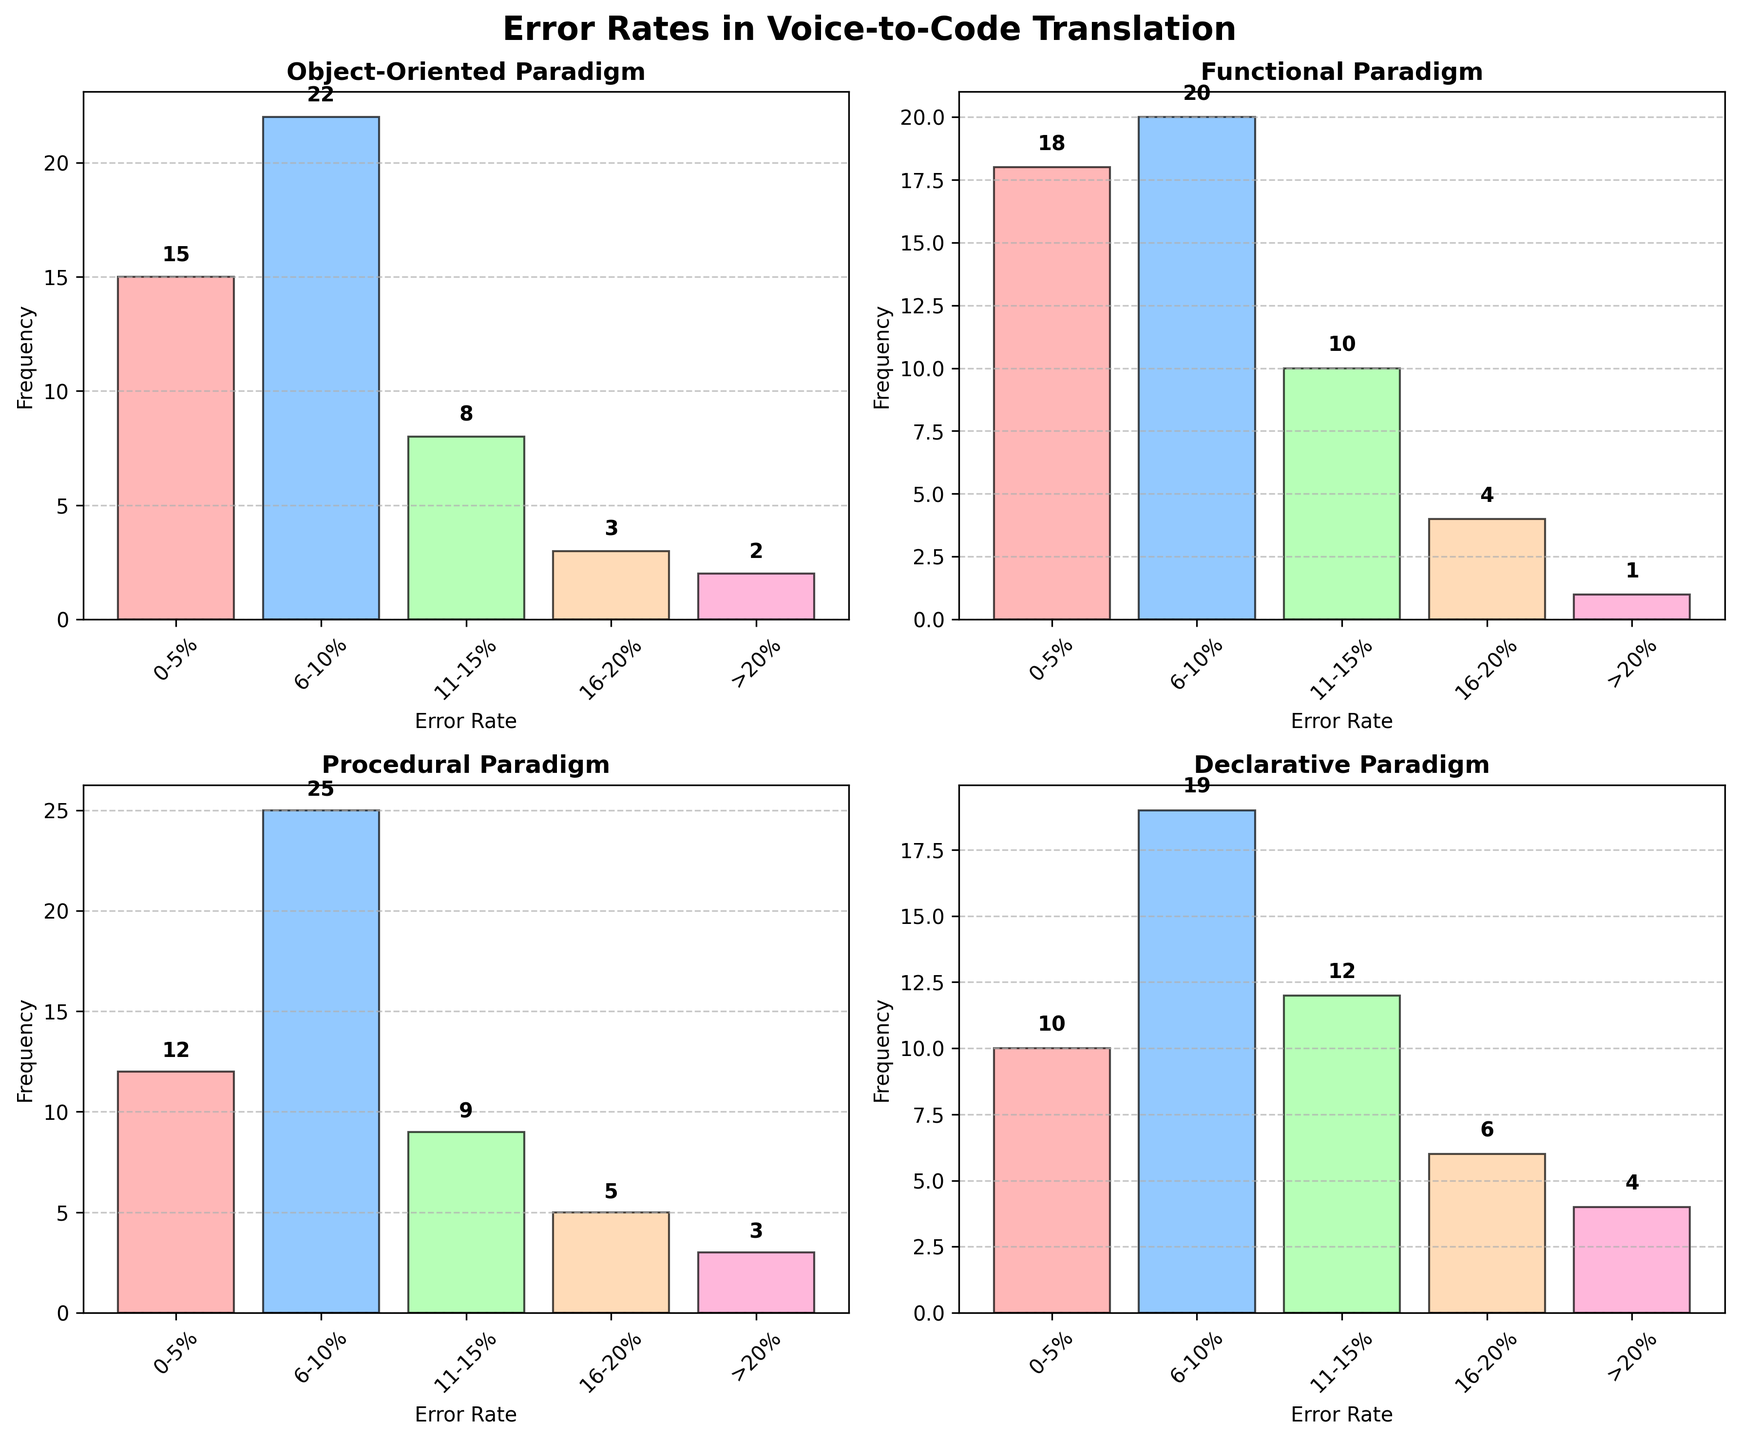How many subplots are there on the figure? The figure contains multiple subplots arranged in a grid. By counting these, we see there are four subplots representing the different programming paradigms.
Answer: Four What paradigm has the highest frequency bar in the "0-5%" error rate category? By comparing the height of the bars in the "0-5%" error rate category across all paradigms, we see that the Functional paradigm has the highest bar with a frequency of 18.
Answer: Functional Which error rate category has the lowest frequency across all paradigms? We need to find the category with the smallest height bar across all subplots. The ">20%" error rate category has the lowest frequencies in all paradigms, particularly in the Functional paradigm, which has a frequency of 1.
Answer: >20% What is the total frequency for the Procedural paradigm? Add up all the frequencies for each error rate category in the Procedural subplot: 12 (0-5%) + 25 (6-10%) + 9 (11-15%) + 5 (16-20%) + 3 (>20%) = 54.
Answer: 54 Which two paradigms have the closest frequencies in the "6-10%" error rate category? Compare the frequencies in the "6-10%" category: Object-Oriented (22), Functional (20), Procedural (25), and Declarative (19). The closest frequencies are between Functional (20) and Declarative (19).
Answer: Functional and Declarative What is the average frequency for the "11-15%" error rate category across all paradigms? Sum the frequencies in the "11-15%" category for each paradigm and then divide by the number of paradigms: 8 (Object-Oriented) + 10 (Functional) + 9 (Procedural) + 12 (Declarative) = 39, and 39/4 = 9.75.
Answer: 9.75 Which paradigm shows the widest spread in frequencies across different error rate categories? Assess the range (difference between highest and lowest frequency) for each paradigm: Object-Oriented (22-2=20), Functional (20-1=19), Procedural (25-3=22), and Declarative (19-4=15). Procedural shows the widest spread with a range of 22.
Answer: Procedural How many error rate categories have more than 15 frequencies in the Object-Oriented paradigm? Look at the Object-Oriented subplot and count categories with frequencies greater than 15: Only the "6-10%" category has a frequency of 22, which is more than 15.
Answer: One What's the median frequency for the Declarative paradigm's error rate categories? List the frequencies for Declarative: 10, 19, 12, 6, 4. Arrange in ascending order: 4, 6, 10, 12, 19. The median frequency is the middle value, which is 10.
Answer: 10 Which paradigm has the lowest total frequency? Compute the sum of frequencies for each paradigm: Object-Oriented (15+22+8+3+2=50), Functional (18+20+10+4+1=53), Procedural (12+25+9+5+3=54), Declarative (10+19+12+6+4=51). Object-Oriented has the lowest at 50.
Answer: Object-Oriented 